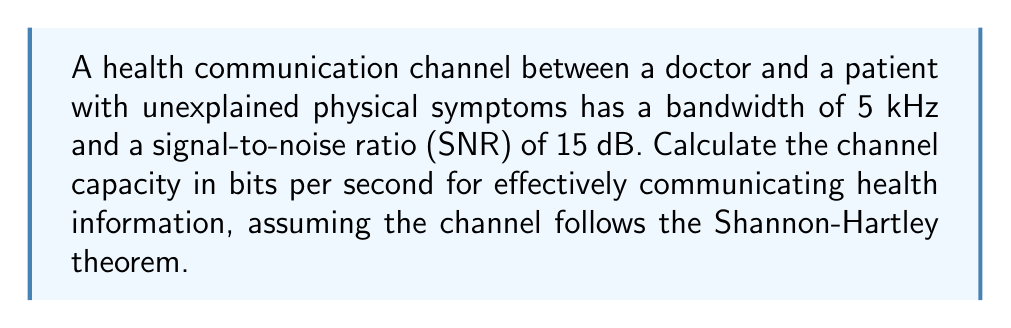Provide a solution to this math problem. To solve this problem, we'll use the Shannon-Hartley theorem, which relates channel capacity to bandwidth and signal-to-noise ratio. The theorem is expressed as:

$$C = B \log_2(1 + SNR)$$

Where:
$C$ = Channel capacity in bits per second
$B$ = Bandwidth in Hz
$SNR$ = Signal-to-noise ratio (linear, not dB)

Given:
- Bandwidth ($B$) = 5 kHz = 5,000 Hz
- SNR = 15 dB

Step 1: Convert SNR from dB to linear scale
SNR in linear scale = $10^{SNR_{dB}/10}$
$SNR_{linear} = 10^{15/10} = 10^{1.5} \approx 31.6228$

Step 2: Apply the Shannon-Hartley theorem
$$\begin{align}
C &= B \log_2(1 + SNR) \\
&= 5000 \cdot \log_2(1 + 31.6228) \\
&= 5000 \cdot \log_2(32.6228)
\end{align}$$

Step 3: Calculate the logarithm
$\log_2(32.6228) \approx 5.0279$

Step 4: Multiply by the bandwidth
$$C = 5000 \cdot 5.0279 \approx 25,139.5$$

Therefore, the channel capacity is approximately 25,139.5 bits per second.
Answer: The channel capacity for effectively communicating health information is approximately 25,140 bits per second. 